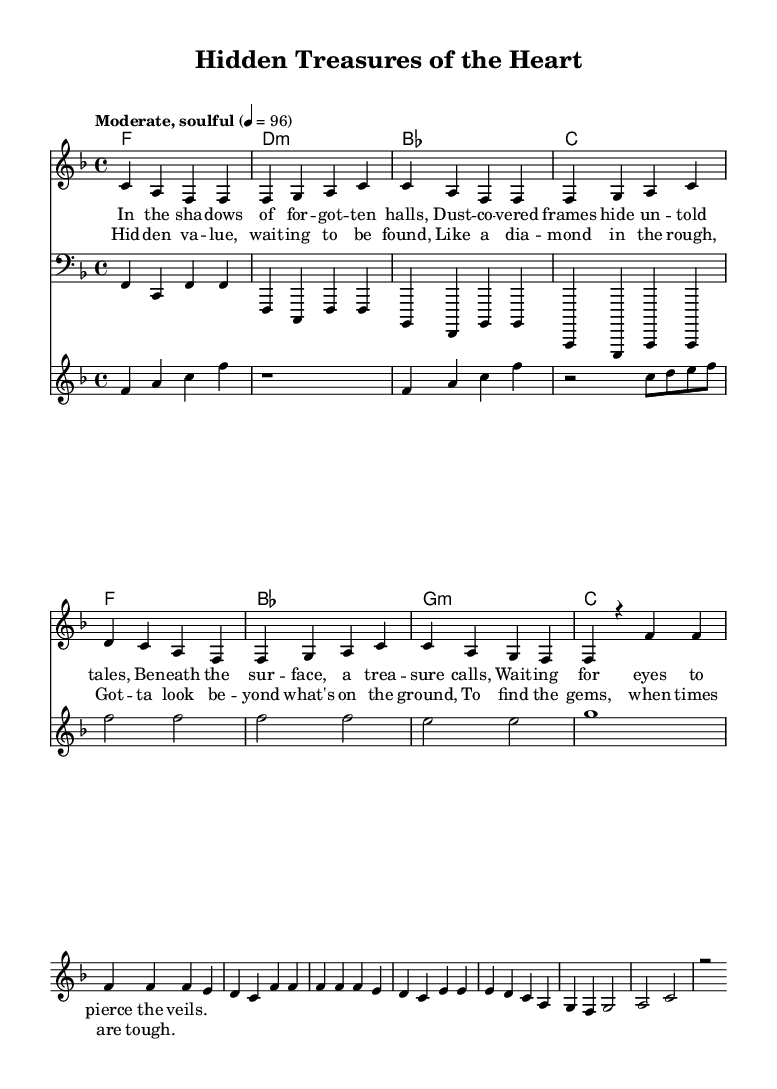What is the key signature of this music? The key signature is indicated by the placement of the sharps or flats at the beginning of the staff. In this case, there are no sharps or flats, which indicates that the piece is in F major.
Answer: F major What is the time signature of this piece? The time signature is found as a fraction at the beginning of the music, directly after the key signature, indicating the number of beats per measure and the note value that gets a beat. Here, it shows 4 over 4, meaning there are four beats in each measure.
Answer: 4/4 What is the tempo marking in the score? The tempo is specified in the music sheet, indicating how fast or slow the piece should be played. In this case, it states "Moderate, soulful," indicating a moderate pace.
Answer: Moderate, soulful How many measures are in the verse? To find the number of measures in the verse, I count the individual segments between the vertical lines that separate each measure in the melody section. The verse consists of four measures.
Answer: four What is the main theme explored in the lyrics of the chorus? The chorus lyrics hint at a central theme through repeated phrases around discovery and value, focusing on finding hidden treasure and looking beyond appearances. This highlights a thematic exploration of hidden value, mirroring the essence of soul music.
Answer: Hidden value How many different chord types are used in the chorus? By examining the chord names listed in the harmony section, I identify each unique chord type used in the chorus. The chords presented are F major, B-flat major, G minor, and C major, totaling four different chord types.
Answer: four Which instrument has the bass line in this score? The score indicates different staves for various instruments. The staff labeled "bass" features the clef that denotes the bass instruments. Therefore, the bass line is played by the bass instrument.
Answer: Bass 